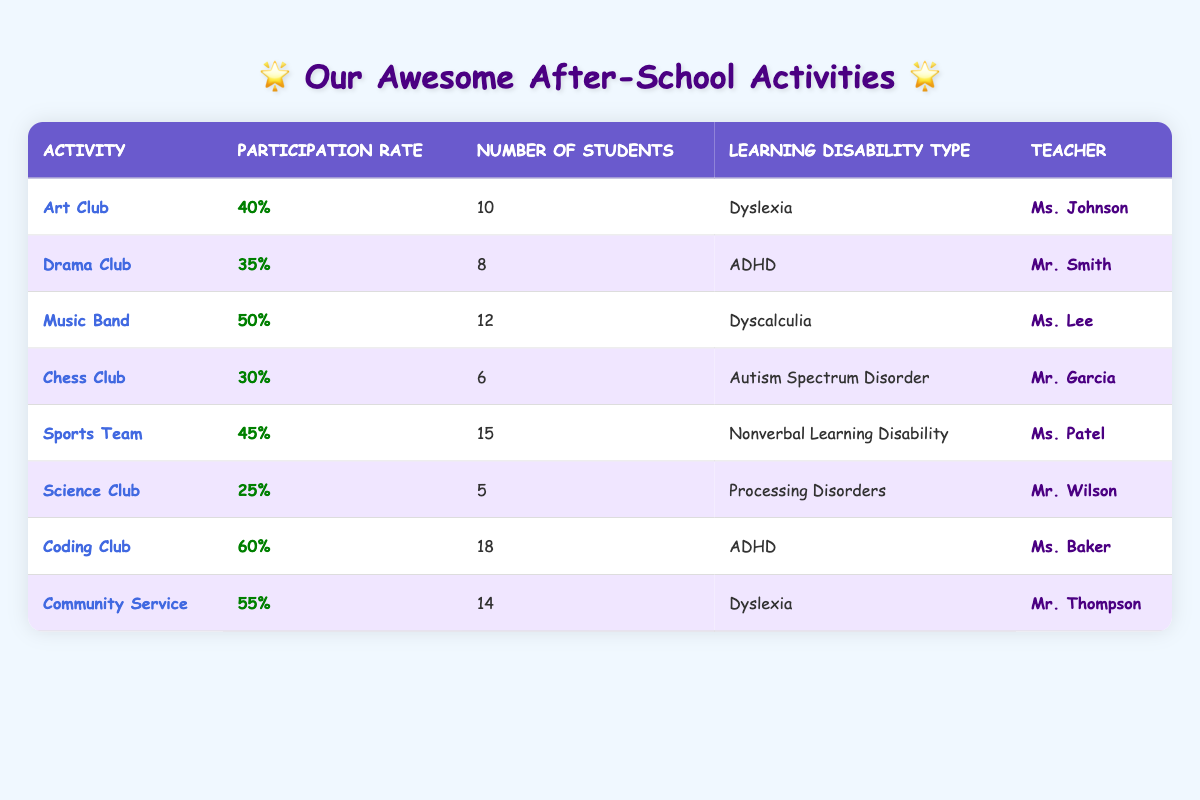What is the participation rate for the Coding Club? The participation rate is listed in the table next to the Coding Club, which shows it as 60%.
Answer: 60% How many students participate in the Sports Team? The table indicates that there are 15 students participating in the Sports Team.
Answer: 15 Which activity has the highest participation rate? Comparing the participation rates in the table, the Coding Club has the highest rate at 60%.
Answer: Coding Club What is the participation rate for Drama Club and Music Band combined? To find the combined participation, add the rates: Drama Club (35%) + Music Band (50%) = 85%.
Answer: 85% Is the participation rate for Science Club less than 30%? The table shows that the participation rate for Science Club is 25%, which is indeed less than 30%.
Answer: Yes How many activities have a participation rate above 50%? The table lists three activities with participation rates above 50%: Coding Club (60%), Community Service (55%), and Music Band (50%), so there are two activities (Coding Club and Community Service).
Answer: 2 What is the average participation rate of all activities? To find the average, sum all participation rates: (40 + 35 + 50 + 30 + 45 + 25 + 60 + 55) = 340. Then divide by the number of activities (8): 340/8 = 42.5%.
Answer: 42.5% Which teacher oversees the Chess Club? The table clearly shows that Mr. Garcia is the teacher for the Chess Club.
Answer: Mr. Garcia What is the difference in participation rates between Music Band and Chess Club? Music Band's rate is 50%, and Chess Club's is 30%. The difference is 50% - 30% = 20%.
Answer: 20% How many students have a Learning Disability type of Dyslexia? There are two activities related to Dyslexia: Art Club (10 students) and Community Service (14 students), hence the total is 10 + 14 = 24 students.
Answer: 24 